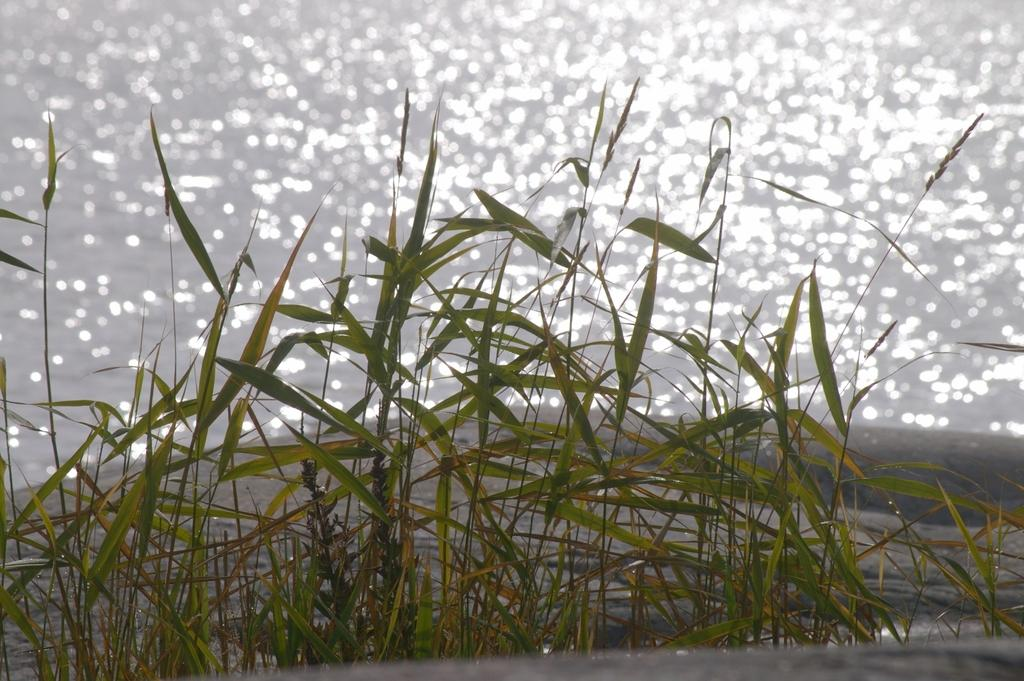What type of plastic force field can be seen protecting the car while it's driving in the image? There is no image provided, and therefore no such force field or driving scene can be observed. 